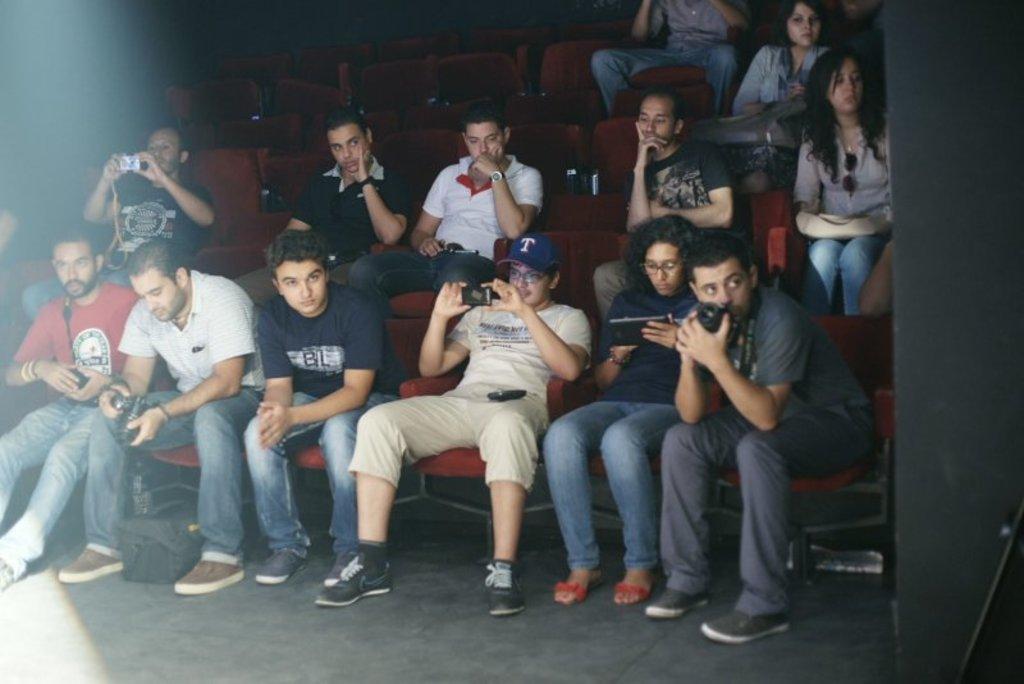Describe this image in one or two sentences. In this image there are persons sitting and there are empty seats and there are persons holding objects in their hands. On the right side there are objects which are black in colour. 